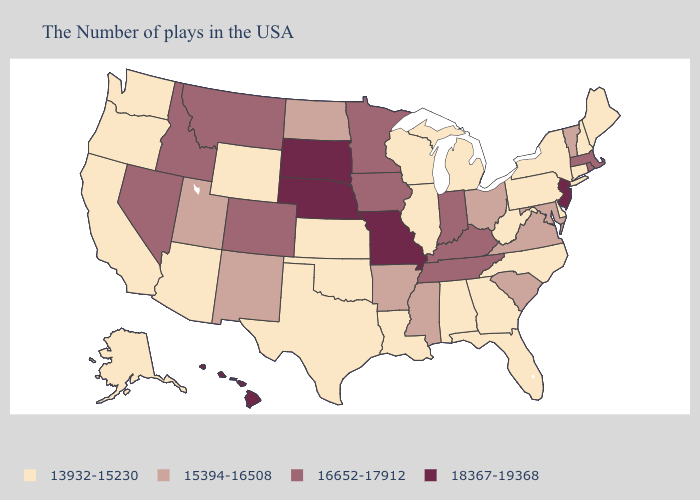Does the first symbol in the legend represent the smallest category?
Concise answer only. Yes. What is the highest value in states that border Delaware?
Keep it brief. 18367-19368. Does New Jersey have the highest value in the Northeast?
Answer briefly. Yes. What is the value of Alaska?
Be succinct. 13932-15230. Does Michigan have the highest value in the USA?
Quick response, please. No. Which states have the lowest value in the Northeast?
Give a very brief answer. Maine, New Hampshire, Connecticut, New York, Pennsylvania. Which states have the lowest value in the Northeast?
Write a very short answer. Maine, New Hampshire, Connecticut, New York, Pennsylvania. What is the value of South Dakota?
Keep it brief. 18367-19368. What is the value of Montana?
Be succinct. 16652-17912. Does Pennsylvania have the highest value in the USA?
Keep it brief. No. Does Vermont have a higher value than Pennsylvania?
Keep it brief. Yes. Does Nebraska have the highest value in the USA?
Write a very short answer. Yes. Which states have the lowest value in the South?
Give a very brief answer. Delaware, North Carolina, West Virginia, Florida, Georgia, Alabama, Louisiana, Oklahoma, Texas. What is the value of Indiana?
Give a very brief answer. 16652-17912. What is the value of Indiana?
Answer briefly. 16652-17912. 